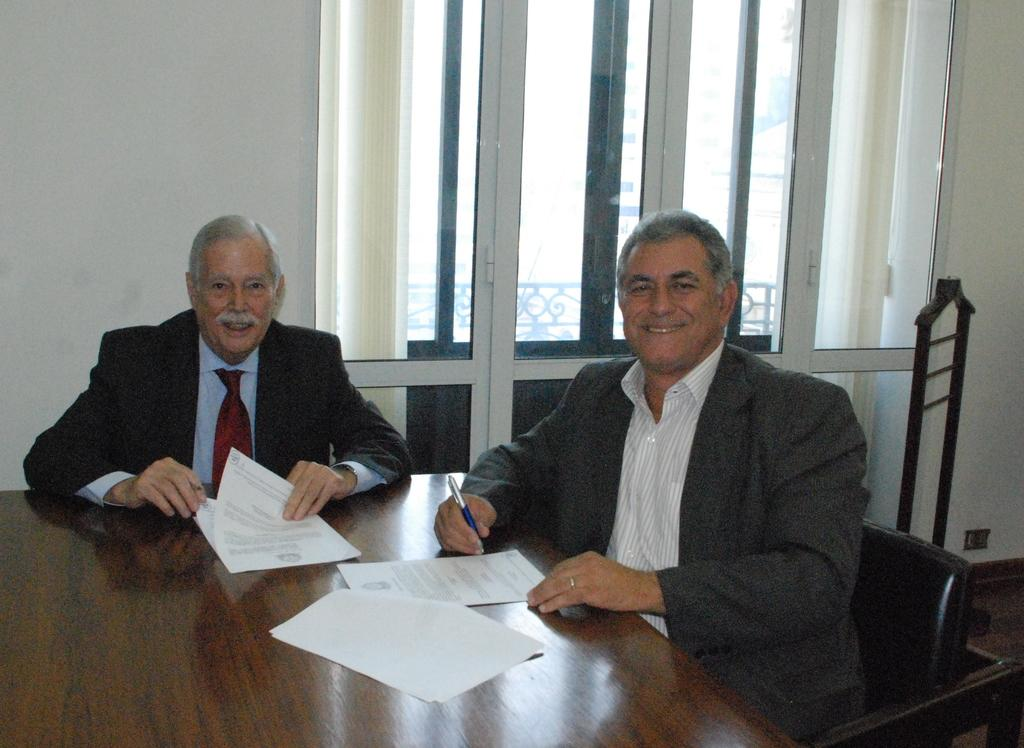How many people are in the image? There are two men in the image. What are the men doing in the image? The men are sitting on chairs and have smiles on their faces. What is present on the table in the image? There is a table in the image, and there are papers on it. What is one of the men holding? One of the men is holding a pen. What type of sock is the loaf wearing in the image? There is no loaf or sock present in the image; it features two men sitting on chairs with smiles on their faces. 